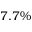Convert formula to latex. <formula><loc_0><loc_0><loc_500><loc_500>7 . 7 \%</formula> 